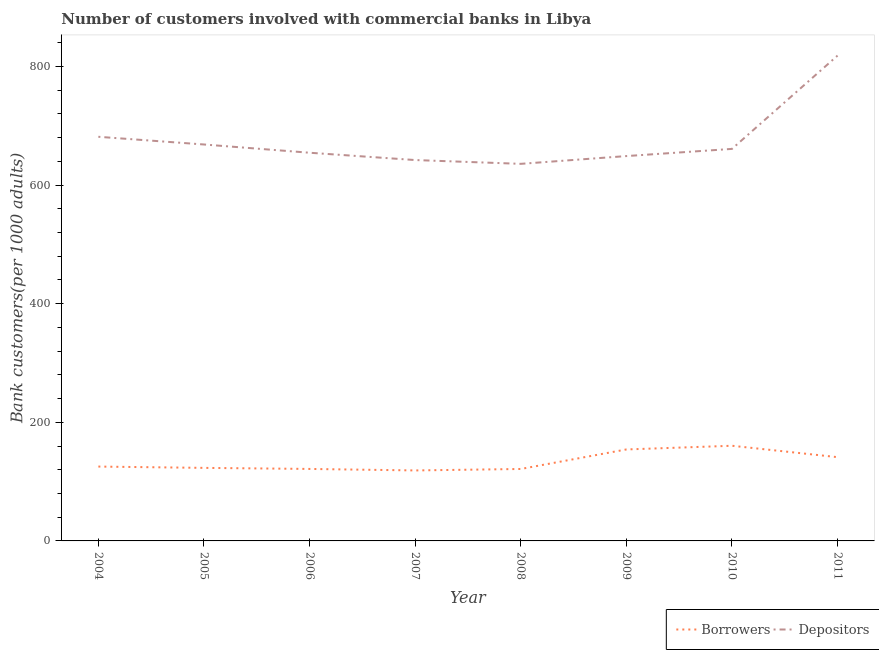Does the line corresponding to number of borrowers intersect with the line corresponding to number of depositors?
Keep it short and to the point. No. What is the number of depositors in 2009?
Your response must be concise. 648.86. Across all years, what is the maximum number of borrowers?
Make the answer very short. 160.45. Across all years, what is the minimum number of borrowers?
Provide a short and direct response. 118.83. In which year was the number of depositors maximum?
Offer a terse response. 2011. In which year was the number of depositors minimum?
Give a very brief answer. 2008. What is the total number of depositors in the graph?
Provide a succinct answer. 5410.24. What is the difference between the number of borrowers in 2004 and that in 2010?
Your answer should be very brief. -35.09. What is the difference between the number of borrowers in 2009 and the number of depositors in 2006?
Give a very brief answer. -500.27. What is the average number of borrowers per year?
Your response must be concise. 133.24. In the year 2011, what is the difference between the number of borrowers and number of depositors?
Provide a succinct answer. -677.01. What is the ratio of the number of depositors in 2004 to that in 2005?
Give a very brief answer. 1.02. Is the number of borrowers in 2005 less than that in 2009?
Keep it short and to the point. Yes. Is the difference between the number of depositors in 2004 and 2006 greater than the difference between the number of borrowers in 2004 and 2006?
Your answer should be very brief. Yes. What is the difference between the highest and the second highest number of borrowers?
Give a very brief answer. 6.22. What is the difference between the highest and the lowest number of depositors?
Offer a terse response. 182.47. In how many years, is the number of depositors greater than the average number of depositors taken over all years?
Keep it short and to the point. 2. Is the sum of the number of depositors in 2005 and 2008 greater than the maximum number of borrowers across all years?
Your answer should be compact. Yes. Is the number of borrowers strictly less than the number of depositors over the years?
Offer a terse response. Yes. Does the graph contain any zero values?
Give a very brief answer. No. Does the graph contain grids?
Ensure brevity in your answer.  No. Where does the legend appear in the graph?
Offer a very short reply. Bottom right. How many legend labels are there?
Give a very brief answer. 2. What is the title of the graph?
Offer a terse response. Number of customers involved with commercial banks in Libya. Does "Food" appear as one of the legend labels in the graph?
Give a very brief answer. No. What is the label or title of the X-axis?
Ensure brevity in your answer.  Year. What is the label or title of the Y-axis?
Make the answer very short. Bank customers(per 1000 adults). What is the Bank customers(per 1000 adults) in Borrowers in 2004?
Provide a short and direct response. 125.36. What is the Bank customers(per 1000 adults) of Depositors in 2004?
Provide a succinct answer. 681.39. What is the Bank customers(per 1000 adults) in Borrowers in 2005?
Your answer should be very brief. 123.15. What is the Bank customers(per 1000 adults) of Depositors in 2005?
Offer a very short reply. 668.4. What is the Bank customers(per 1000 adults) in Borrowers in 2006?
Provide a succinct answer. 121.36. What is the Bank customers(per 1000 adults) of Depositors in 2006?
Your answer should be compact. 654.49. What is the Bank customers(per 1000 adults) in Borrowers in 2007?
Your answer should be compact. 118.83. What is the Bank customers(per 1000 adults) in Depositors in 2007?
Your answer should be compact. 642.16. What is the Bank customers(per 1000 adults) of Borrowers in 2008?
Offer a very short reply. 121.31. What is the Bank customers(per 1000 adults) in Depositors in 2008?
Your answer should be compact. 635.76. What is the Bank customers(per 1000 adults) in Borrowers in 2009?
Provide a short and direct response. 154.22. What is the Bank customers(per 1000 adults) in Depositors in 2009?
Keep it short and to the point. 648.86. What is the Bank customers(per 1000 adults) in Borrowers in 2010?
Make the answer very short. 160.45. What is the Bank customers(per 1000 adults) of Depositors in 2010?
Offer a terse response. 660.95. What is the Bank customers(per 1000 adults) in Borrowers in 2011?
Provide a succinct answer. 141.22. What is the Bank customers(per 1000 adults) in Depositors in 2011?
Provide a short and direct response. 818.23. Across all years, what is the maximum Bank customers(per 1000 adults) in Borrowers?
Keep it short and to the point. 160.45. Across all years, what is the maximum Bank customers(per 1000 adults) in Depositors?
Your answer should be very brief. 818.23. Across all years, what is the minimum Bank customers(per 1000 adults) in Borrowers?
Your response must be concise. 118.83. Across all years, what is the minimum Bank customers(per 1000 adults) of Depositors?
Provide a short and direct response. 635.76. What is the total Bank customers(per 1000 adults) of Borrowers in the graph?
Ensure brevity in your answer.  1065.91. What is the total Bank customers(per 1000 adults) of Depositors in the graph?
Offer a very short reply. 5410.24. What is the difference between the Bank customers(per 1000 adults) in Borrowers in 2004 and that in 2005?
Your response must be concise. 2.21. What is the difference between the Bank customers(per 1000 adults) in Depositors in 2004 and that in 2005?
Keep it short and to the point. 12.99. What is the difference between the Bank customers(per 1000 adults) of Borrowers in 2004 and that in 2006?
Offer a very short reply. 4. What is the difference between the Bank customers(per 1000 adults) of Depositors in 2004 and that in 2006?
Provide a short and direct response. 26.9. What is the difference between the Bank customers(per 1000 adults) of Borrowers in 2004 and that in 2007?
Give a very brief answer. 6.52. What is the difference between the Bank customers(per 1000 adults) in Depositors in 2004 and that in 2007?
Ensure brevity in your answer.  39.23. What is the difference between the Bank customers(per 1000 adults) in Borrowers in 2004 and that in 2008?
Ensure brevity in your answer.  4.05. What is the difference between the Bank customers(per 1000 adults) of Depositors in 2004 and that in 2008?
Provide a short and direct response. 45.63. What is the difference between the Bank customers(per 1000 adults) in Borrowers in 2004 and that in 2009?
Make the answer very short. -28.86. What is the difference between the Bank customers(per 1000 adults) of Depositors in 2004 and that in 2009?
Give a very brief answer. 32.53. What is the difference between the Bank customers(per 1000 adults) of Borrowers in 2004 and that in 2010?
Ensure brevity in your answer.  -35.09. What is the difference between the Bank customers(per 1000 adults) in Depositors in 2004 and that in 2010?
Ensure brevity in your answer.  20.43. What is the difference between the Bank customers(per 1000 adults) in Borrowers in 2004 and that in 2011?
Offer a very short reply. -15.86. What is the difference between the Bank customers(per 1000 adults) in Depositors in 2004 and that in 2011?
Provide a short and direct response. -136.84. What is the difference between the Bank customers(per 1000 adults) of Borrowers in 2005 and that in 2006?
Offer a very short reply. 1.79. What is the difference between the Bank customers(per 1000 adults) in Depositors in 2005 and that in 2006?
Make the answer very short. 13.9. What is the difference between the Bank customers(per 1000 adults) of Borrowers in 2005 and that in 2007?
Offer a very short reply. 4.32. What is the difference between the Bank customers(per 1000 adults) of Depositors in 2005 and that in 2007?
Your answer should be compact. 26.24. What is the difference between the Bank customers(per 1000 adults) of Borrowers in 2005 and that in 2008?
Provide a succinct answer. 1.84. What is the difference between the Bank customers(per 1000 adults) in Depositors in 2005 and that in 2008?
Provide a succinct answer. 32.63. What is the difference between the Bank customers(per 1000 adults) of Borrowers in 2005 and that in 2009?
Ensure brevity in your answer.  -31.07. What is the difference between the Bank customers(per 1000 adults) of Depositors in 2005 and that in 2009?
Provide a succinct answer. 19.53. What is the difference between the Bank customers(per 1000 adults) of Borrowers in 2005 and that in 2010?
Ensure brevity in your answer.  -37.3. What is the difference between the Bank customers(per 1000 adults) in Depositors in 2005 and that in 2010?
Offer a very short reply. 7.44. What is the difference between the Bank customers(per 1000 adults) in Borrowers in 2005 and that in 2011?
Ensure brevity in your answer.  -18.07. What is the difference between the Bank customers(per 1000 adults) of Depositors in 2005 and that in 2011?
Your answer should be very brief. -149.83. What is the difference between the Bank customers(per 1000 adults) in Borrowers in 2006 and that in 2007?
Your answer should be compact. 2.53. What is the difference between the Bank customers(per 1000 adults) in Depositors in 2006 and that in 2007?
Your response must be concise. 12.33. What is the difference between the Bank customers(per 1000 adults) in Borrowers in 2006 and that in 2008?
Provide a short and direct response. 0.06. What is the difference between the Bank customers(per 1000 adults) of Depositors in 2006 and that in 2008?
Your answer should be compact. 18.73. What is the difference between the Bank customers(per 1000 adults) in Borrowers in 2006 and that in 2009?
Ensure brevity in your answer.  -32.86. What is the difference between the Bank customers(per 1000 adults) of Depositors in 2006 and that in 2009?
Your response must be concise. 5.63. What is the difference between the Bank customers(per 1000 adults) in Borrowers in 2006 and that in 2010?
Your answer should be very brief. -39.08. What is the difference between the Bank customers(per 1000 adults) of Depositors in 2006 and that in 2010?
Make the answer very short. -6.46. What is the difference between the Bank customers(per 1000 adults) of Borrowers in 2006 and that in 2011?
Provide a succinct answer. -19.86. What is the difference between the Bank customers(per 1000 adults) in Depositors in 2006 and that in 2011?
Your answer should be compact. -163.74. What is the difference between the Bank customers(per 1000 adults) in Borrowers in 2007 and that in 2008?
Make the answer very short. -2.47. What is the difference between the Bank customers(per 1000 adults) of Depositors in 2007 and that in 2008?
Keep it short and to the point. 6.4. What is the difference between the Bank customers(per 1000 adults) in Borrowers in 2007 and that in 2009?
Keep it short and to the point. -35.39. What is the difference between the Bank customers(per 1000 adults) of Depositors in 2007 and that in 2009?
Your response must be concise. -6.7. What is the difference between the Bank customers(per 1000 adults) in Borrowers in 2007 and that in 2010?
Keep it short and to the point. -41.61. What is the difference between the Bank customers(per 1000 adults) in Depositors in 2007 and that in 2010?
Ensure brevity in your answer.  -18.8. What is the difference between the Bank customers(per 1000 adults) of Borrowers in 2007 and that in 2011?
Keep it short and to the point. -22.39. What is the difference between the Bank customers(per 1000 adults) of Depositors in 2007 and that in 2011?
Your answer should be very brief. -176.07. What is the difference between the Bank customers(per 1000 adults) of Borrowers in 2008 and that in 2009?
Provide a succinct answer. -32.92. What is the difference between the Bank customers(per 1000 adults) in Depositors in 2008 and that in 2009?
Provide a short and direct response. -13.1. What is the difference between the Bank customers(per 1000 adults) in Borrowers in 2008 and that in 2010?
Offer a terse response. -39.14. What is the difference between the Bank customers(per 1000 adults) in Depositors in 2008 and that in 2010?
Give a very brief answer. -25.19. What is the difference between the Bank customers(per 1000 adults) in Borrowers in 2008 and that in 2011?
Provide a short and direct response. -19.92. What is the difference between the Bank customers(per 1000 adults) of Depositors in 2008 and that in 2011?
Give a very brief answer. -182.47. What is the difference between the Bank customers(per 1000 adults) of Borrowers in 2009 and that in 2010?
Provide a short and direct response. -6.22. What is the difference between the Bank customers(per 1000 adults) in Depositors in 2009 and that in 2010?
Offer a very short reply. -12.09. What is the difference between the Bank customers(per 1000 adults) in Borrowers in 2009 and that in 2011?
Your response must be concise. 13. What is the difference between the Bank customers(per 1000 adults) of Depositors in 2009 and that in 2011?
Offer a terse response. -169.37. What is the difference between the Bank customers(per 1000 adults) of Borrowers in 2010 and that in 2011?
Provide a short and direct response. 19.22. What is the difference between the Bank customers(per 1000 adults) in Depositors in 2010 and that in 2011?
Your response must be concise. -157.27. What is the difference between the Bank customers(per 1000 adults) in Borrowers in 2004 and the Bank customers(per 1000 adults) in Depositors in 2005?
Keep it short and to the point. -543.04. What is the difference between the Bank customers(per 1000 adults) of Borrowers in 2004 and the Bank customers(per 1000 adults) of Depositors in 2006?
Keep it short and to the point. -529.13. What is the difference between the Bank customers(per 1000 adults) of Borrowers in 2004 and the Bank customers(per 1000 adults) of Depositors in 2007?
Provide a short and direct response. -516.8. What is the difference between the Bank customers(per 1000 adults) of Borrowers in 2004 and the Bank customers(per 1000 adults) of Depositors in 2008?
Your answer should be compact. -510.4. What is the difference between the Bank customers(per 1000 adults) of Borrowers in 2004 and the Bank customers(per 1000 adults) of Depositors in 2009?
Offer a very short reply. -523.5. What is the difference between the Bank customers(per 1000 adults) in Borrowers in 2004 and the Bank customers(per 1000 adults) in Depositors in 2010?
Keep it short and to the point. -535.6. What is the difference between the Bank customers(per 1000 adults) of Borrowers in 2004 and the Bank customers(per 1000 adults) of Depositors in 2011?
Provide a succinct answer. -692.87. What is the difference between the Bank customers(per 1000 adults) in Borrowers in 2005 and the Bank customers(per 1000 adults) in Depositors in 2006?
Offer a terse response. -531.34. What is the difference between the Bank customers(per 1000 adults) in Borrowers in 2005 and the Bank customers(per 1000 adults) in Depositors in 2007?
Keep it short and to the point. -519.01. What is the difference between the Bank customers(per 1000 adults) of Borrowers in 2005 and the Bank customers(per 1000 adults) of Depositors in 2008?
Your answer should be very brief. -512.61. What is the difference between the Bank customers(per 1000 adults) in Borrowers in 2005 and the Bank customers(per 1000 adults) in Depositors in 2009?
Provide a succinct answer. -525.71. What is the difference between the Bank customers(per 1000 adults) of Borrowers in 2005 and the Bank customers(per 1000 adults) of Depositors in 2010?
Your answer should be very brief. -537.8. What is the difference between the Bank customers(per 1000 adults) of Borrowers in 2005 and the Bank customers(per 1000 adults) of Depositors in 2011?
Keep it short and to the point. -695.08. What is the difference between the Bank customers(per 1000 adults) of Borrowers in 2006 and the Bank customers(per 1000 adults) of Depositors in 2007?
Your response must be concise. -520.79. What is the difference between the Bank customers(per 1000 adults) of Borrowers in 2006 and the Bank customers(per 1000 adults) of Depositors in 2008?
Your answer should be very brief. -514.4. What is the difference between the Bank customers(per 1000 adults) of Borrowers in 2006 and the Bank customers(per 1000 adults) of Depositors in 2009?
Your answer should be very brief. -527.5. What is the difference between the Bank customers(per 1000 adults) of Borrowers in 2006 and the Bank customers(per 1000 adults) of Depositors in 2010?
Make the answer very short. -539.59. What is the difference between the Bank customers(per 1000 adults) in Borrowers in 2006 and the Bank customers(per 1000 adults) in Depositors in 2011?
Give a very brief answer. -696.87. What is the difference between the Bank customers(per 1000 adults) of Borrowers in 2007 and the Bank customers(per 1000 adults) of Depositors in 2008?
Ensure brevity in your answer.  -516.93. What is the difference between the Bank customers(per 1000 adults) of Borrowers in 2007 and the Bank customers(per 1000 adults) of Depositors in 2009?
Provide a short and direct response. -530.03. What is the difference between the Bank customers(per 1000 adults) of Borrowers in 2007 and the Bank customers(per 1000 adults) of Depositors in 2010?
Give a very brief answer. -542.12. What is the difference between the Bank customers(per 1000 adults) of Borrowers in 2007 and the Bank customers(per 1000 adults) of Depositors in 2011?
Provide a short and direct response. -699.39. What is the difference between the Bank customers(per 1000 adults) of Borrowers in 2008 and the Bank customers(per 1000 adults) of Depositors in 2009?
Keep it short and to the point. -527.55. What is the difference between the Bank customers(per 1000 adults) of Borrowers in 2008 and the Bank customers(per 1000 adults) of Depositors in 2010?
Keep it short and to the point. -539.65. What is the difference between the Bank customers(per 1000 adults) of Borrowers in 2008 and the Bank customers(per 1000 adults) of Depositors in 2011?
Your answer should be very brief. -696.92. What is the difference between the Bank customers(per 1000 adults) in Borrowers in 2009 and the Bank customers(per 1000 adults) in Depositors in 2010?
Keep it short and to the point. -506.73. What is the difference between the Bank customers(per 1000 adults) of Borrowers in 2009 and the Bank customers(per 1000 adults) of Depositors in 2011?
Give a very brief answer. -664.01. What is the difference between the Bank customers(per 1000 adults) in Borrowers in 2010 and the Bank customers(per 1000 adults) in Depositors in 2011?
Ensure brevity in your answer.  -657.78. What is the average Bank customers(per 1000 adults) in Borrowers per year?
Keep it short and to the point. 133.24. What is the average Bank customers(per 1000 adults) of Depositors per year?
Give a very brief answer. 676.28. In the year 2004, what is the difference between the Bank customers(per 1000 adults) of Borrowers and Bank customers(per 1000 adults) of Depositors?
Offer a very short reply. -556.03. In the year 2005, what is the difference between the Bank customers(per 1000 adults) of Borrowers and Bank customers(per 1000 adults) of Depositors?
Provide a succinct answer. -545.24. In the year 2006, what is the difference between the Bank customers(per 1000 adults) of Borrowers and Bank customers(per 1000 adults) of Depositors?
Your answer should be compact. -533.13. In the year 2007, what is the difference between the Bank customers(per 1000 adults) of Borrowers and Bank customers(per 1000 adults) of Depositors?
Keep it short and to the point. -523.32. In the year 2008, what is the difference between the Bank customers(per 1000 adults) of Borrowers and Bank customers(per 1000 adults) of Depositors?
Keep it short and to the point. -514.45. In the year 2009, what is the difference between the Bank customers(per 1000 adults) of Borrowers and Bank customers(per 1000 adults) of Depositors?
Offer a terse response. -494.64. In the year 2010, what is the difference between the Bank customers(per 1000 adults) of Borrowers and Bank customers(per 1000 adults) of Depositors?
Your answer should be very brief. -500.51. In the year 2011, what is the difference between the Bank customers(per 1000 adults) in Borrowers and Bank customers(per 1000 adults) in Depositors?
Provide a short and direct response. -677.01. What is the ratio of the Bank customers(per 1000 adults) of Borrowers in 2004 to that in 2005?
Your answer should be compact. 1.02. What is the ratio of the Bank customers(per 1000 adults) of Depositors in 2004 to that in 2005?
Make the answer very short. 1.02. What is the ratio of the Bank customers(per 1000 adults) in Borrowers in 2004 to that in 2006?
Offer a very short reply. 1.03. What is the ratio of the Bank customers(per 1000 adults) of Depositors in 2004 to that in 2006?
Offer a very short reply. 1.04. What is the ratio of the Bank customers(per 1000 adults) in Borrowers in 2004 to that in 2007?
Give a very brief answer. 1.05. What is the ratio of the Bank customers(per 1000 adults) in Depositors in 2004 to that in 2007?
Make the answer very short. 1.06. What is the ratio of the Bank customers(per 1000 adults) in Borrowers in 2004 to that in 2008?
Offer a terse response. 1.03. What is the ratio of the Bank customers(per 1000 adults) in Depositors in 2004 to that in 2008?
Offer a terse response. 1.07. What is the ratio of the Bank customers(per 1000 adults) of Borrowers in 2004 to that in 2009?
Provide a short and direct response. 0.81. What is the ratio of the Bank customers(per 1000 adults) in Depositors in 2004 to that in 2009?
Your response must be concise. 1.05. What is the ratio of the Bank customers(per 1000 adults) of Borrowers in 2004 to that in 2010?
Make the answer very short. 0.78. What is the ratio of the Bank customers(per 1000 adults) of Depositors in 2004 to that in 2010?
Your answer should be very brief. 1.03. What is the ratio of the Bank customers(per 1000 adults) in Borrowers in 2004 to that in 2011?
Ensure brevity in your answer.  0.89. What is the ratio of the Bank customers(per 1000 adults) in Depositors in 2004 to that in 2011?
Keep it short and to the point. 0.83. What is the ratio of the Bank customers(per 1000 adults) in Borrowers in 2005 to that in 2006?
Your response must be concise. 1.01. What is the ratio of the Bank customers(per 1000 adults) in Depositors in 2005 to that in 2006?
Make the answer very short. 1.02. What is the ratio of the Bank customers(per 1000 adults) of Borrowers in 2005 to that in 2007?
Your answer should be compact. 1.04. What is the ratio of the Bank customers(per 1000 adults) in Depositors in 2005 to that in 2007?
Ensure brevity in your answer.  1.04. What is the ratio of the Bank customers(per 1000 adults) of Borrowers in 2005 to that in 2008?
Your response must be concise. 1.02. What is the ratio of the Bank customers(per 1000 adults) in Depositors in 2005 to that in 2008?
Your answer should be very brief. 1.05. What is the ratio of the Bank customers(per 1000 adults) in Borrowers in 2005 to that in 2009?
Offer a very short reply. 0.8. What is the ratio of the Bank customers(per 1000 adults) in Depositors in 2005 to that in 2009?
Your answer should be very brief. 1.03. What is the ratio of the Bank customers(per 1000 adults) of Borrowers in 2005 to that in 2010?
Offer a terse response. 0.77. What is the ratio of the Bank customers(per 1000 adults) of Depositors in 2005 to that in 2010?
Give a very brief answer. 1.01. What is the ratio of the Bank customers(per 1000 adults) in Borrowers in 2005 to that in 2011?
Give a very brief answer. 0.87. What is the ratio of the Bank customers(per 1000 adults) in Depositors in 2005 to that in 2011?
Your answer should be compact. 0.82. What is the ratio of the Bank customers(per 1000 adults) in Borrowers in 2006 to that in 2007?
Offer a very short reply. 1.02. What is the ratio of the Bank customers(per 1000 adults) in Depositors in 2006 to that in 2007?
Make the answer very short. 1.02. What is the ratio of the Bank customers(per 1000 adults) of Borrowers in 2006 to that in 2008?
Offer a terse response. 1. What is the ratio of the Bank customers(per 1000 adults) of Depositors in 2006 to that in 2008?
Ensure brevity in your answer.  1.03. What is the ratio of the Bank customers(per 1000 adults) of Borrowers in 2006 to that in 2009?
Offer a terse response. 0.79. What is the ratio of the Bank customers(per 1000 adults) in Depositors in 2006 to that in 2009?
Provide a short and direct response. 1.01. What is the ratio of the Bank customers(per 1000 adults) in Borrowers in 2006 to that in 2010?
Provide a succinct answer. 0.76. What is the ratio of the Bank customers(per 1000 adults) in Depositors in 2006 to that in 2010?
Your answer should be compact. 0.99. What is the ratio of the Bank customers(per 1000 adults) in Borrowers in 2006 to that in 2011?
Offer a very short reply. 0.86. What is the ratio of the Bank customers(per 1000 adults) of Depositors in 2006 to that in 2011?
Offer a terse response. 0.8. What is the ratio of the Bank customers(per 1000 adults) in Borrowers in 2007 to that in 2008?
Your answer should be very brief. 0.98. What is the ratio of the Bank customers(per 1000 adults) of Borrowers in 2007 to that in 2009?
Your response must be concise. 0.77. What is the ratio of the Bank customers(per 1000 adults) in Borrowers in 2007 to that in 2010?
Offer a very short reply. 0.74. What is the ratio of the Bank customers(per 1000 adults) in Depositors in 2007 to that in 2010?
Ensure brevity in your answer.  0.97. What is the ratio of the Bank customers(per 1000 adults) in Borrowers in 2007 to that in 2011?
Give a very brief answer. 0.84. What is the ratio of the Bank customers(per 1000 adults) in Depositors in 2007 to that in 2011?
Ensure brevity in your answer.  0.78. What is the ratio of the Bank customers(per 1000 adults) in Borrowers in 2008 to that in 2009?
Offer a very short reply. 0.79. What is the ratio of the Bank customers(per 1000 adults) of Depositors in 2008 to that in 2009?
Your answer should be very brief. 0.98. What is the ratio of the Bank customers(per 1000 adults) in Borrowers in 2008 to that in 2010?
Provide a succinct answer. 0.76. What is the ratio of the Bank customers(per 1000 adults) of Depositors in 2008 to that in 2010?
Your answer should be compact. 0.96. What is the ratio of the Bank customers(per 1000 adults) of Borrowers in 2008 to that in 2011?
Offer a very short reply. 0.86. What is the ratio of the Bank customers(per 1000 adults) in Depositors in 2008 to that in 2011?
Your response must be concise. 0.78. What is the ratio of the Bank customers(per 1000 adults) of Borrowers in 2009 to that in 2010?
Give a very brief answer. 0.96. What is the ratio of the Bank customers(per 1000 adults) of Depositors in 2009 to that in 2010?
Offer a very short reply. 0.98. What is the ratio of the Bank customers(per 1000 adults) of Borrowers in 2009 to that in 2011?
Provide a short and direct response. 1.09. What is the ratio of the Bank customers(per 1000 adults) in Depositors in 2009 to that in 2011?
Offer a terse response. 0.79. What is the ratio of the Bank customers(per 1000 adults) of Borrowers in 2010 to that in 2011?
Offer a terse response. 1.14. What is the ratio of the Bank customers(per 1000 adults) of Depositors in 2010 to that in 2011?
Offer a very short reply. 0.81. What is the difference between the highest and the second highest Bank customers(per 1000 adults) in Borrowers?
Your answer should be very brief. 6.22. What is the difference between the highest and the second highest Bank customers(per 1000 adults) of Depositors?
Your answer should be compact. 136.84. What is the difference between the highest and the lowest Bank customers(per 1000 adults) in Borrowers?
Your answer should be compact. 41.61. What is the difference between the highest and the lowest Bank customers(per 1000 adults) in Depositors?
Your answer should be very brief. 182.47. 